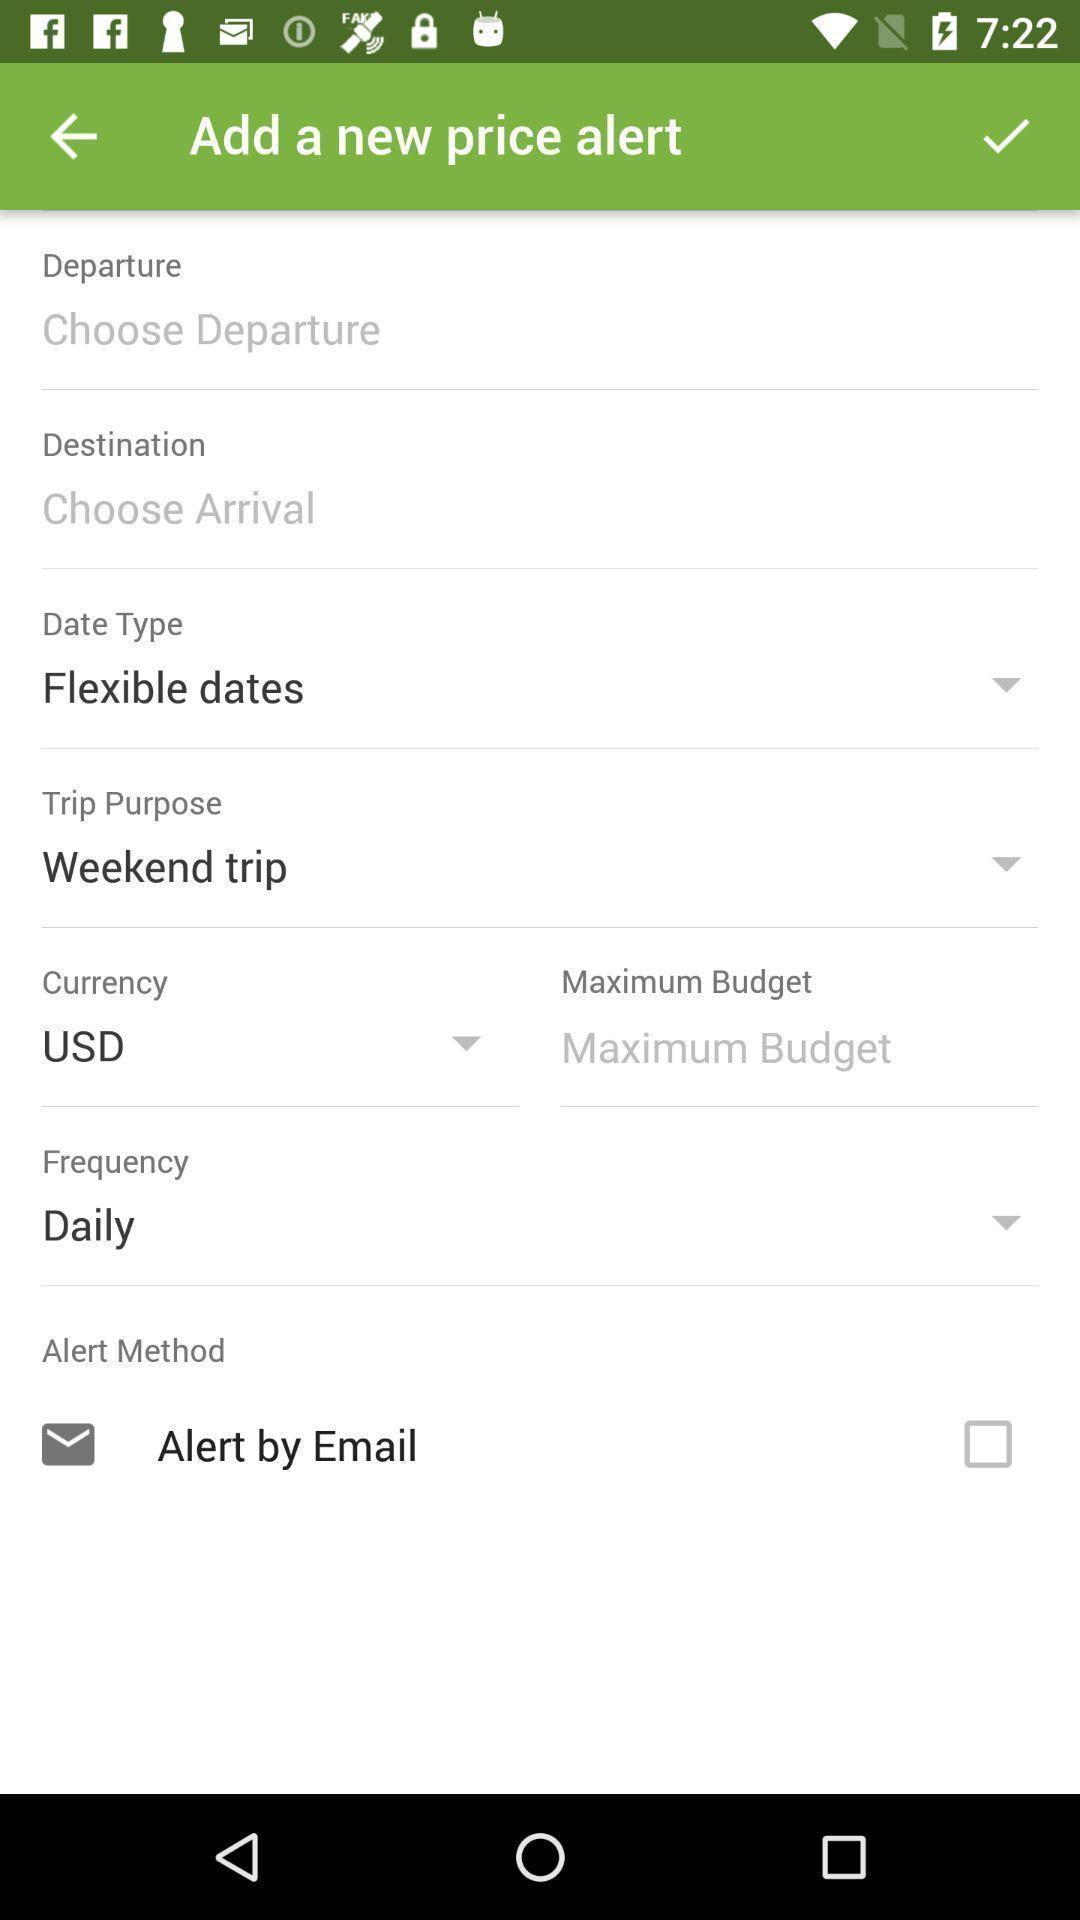Explain what's happening in this screen capture. Screen displaying multiple options in an airline booking application. 